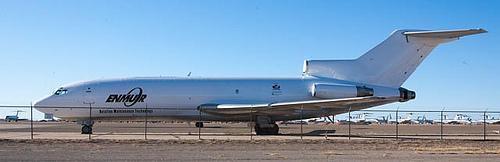How many fences are there?
Give a very brief answer. 1. 